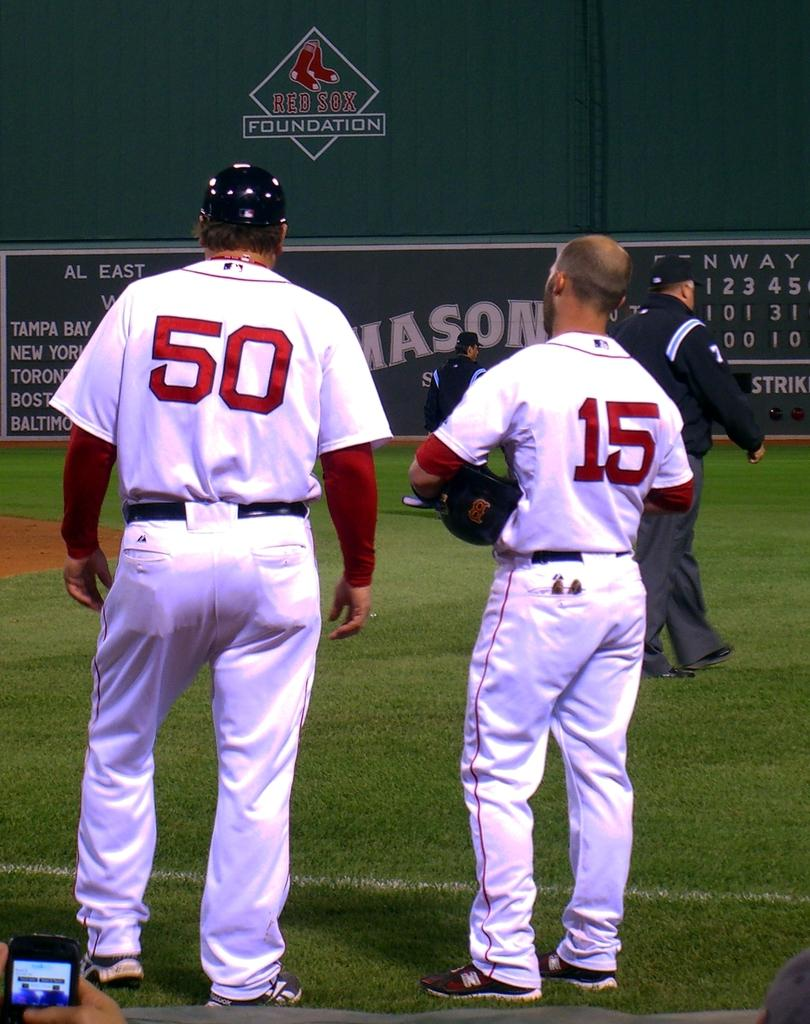Provide a one-sentence caption for the provided image. Baseball players on the field wearing 50 and 15 jerseys. 